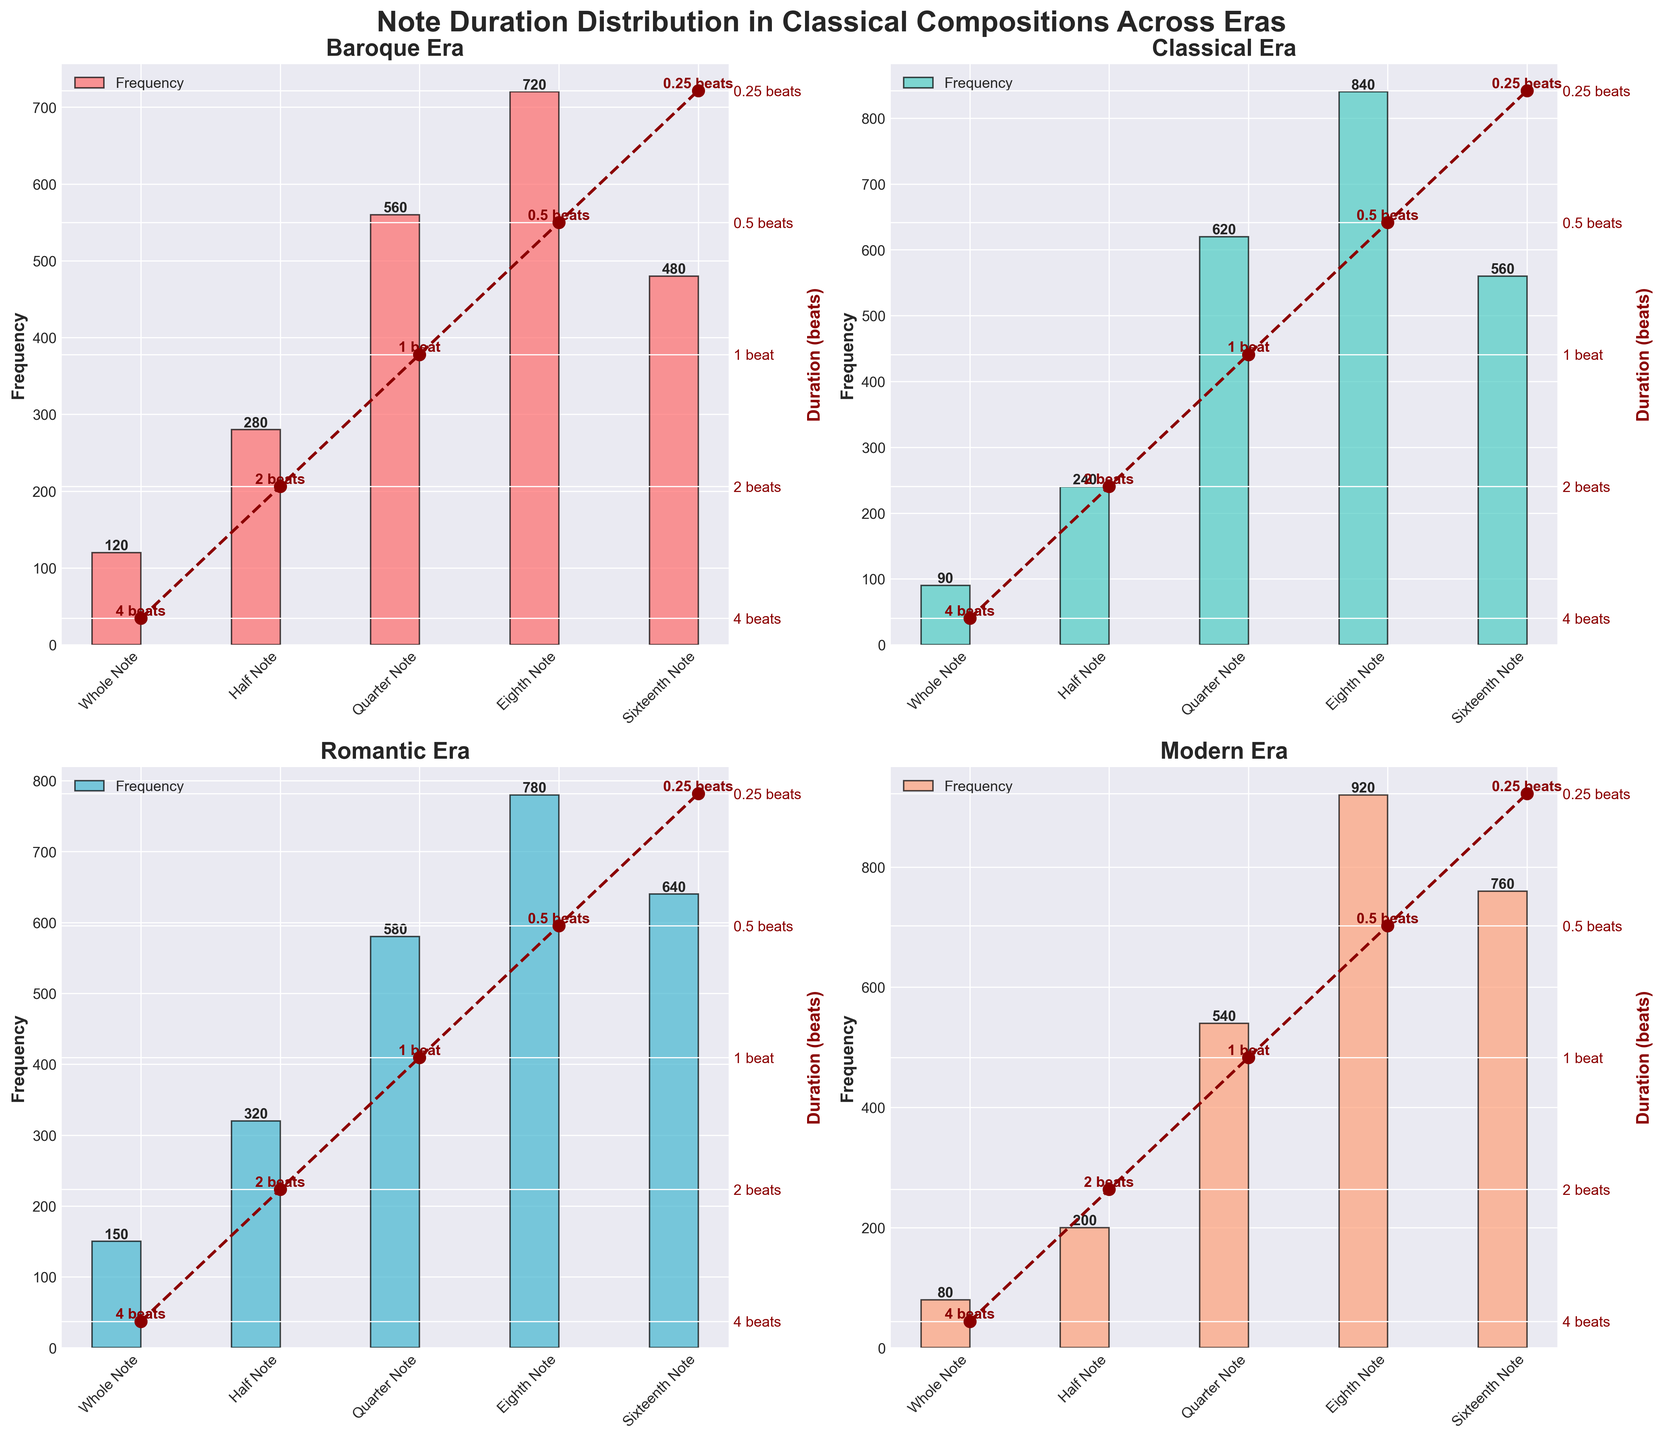What is the title of the figure? The title is the largest and topmost text, helping to contextualize the visual information. It reads "Note Duration Distribution in Classical Compositions Across Eras".
Answer: Note Duration Distribution in Classical Compositions Across Eras Which era has the highest frequency of Eighth Notes? To find the highest frequency of Eighth Notes, identify the Eighth Note for each era and compare their values. The Modern era shows the highest frequency of 920 for Eighth Notes.
Answer: Modern How many subplots are there in the figure? Count the individual charts arranged within the figure. There are a total of 4 subplots, one for each era (Baroque, Classical, Romantic, Modern).
Answer: 4 Which era has the lowest frequency of Whole Notes? Identify the bar representing Whole Notes in each subplot and compare their heights to find the smallest one. The Modern era has the lowest frequency of Whole Notes at 80.
Answer: Modern What is the difference in frequency of Half Notes between the Classical and Romantic eras? Find the frequency of Half Notes for both eras and subtract the lower from the higher. Classical has 240, and Romantic has 320, so the difference is 320 - 240 = 80.
Answer: 80 Among all the eras, which note type has the highest frequency and what is that frequency? Compare the heights of all bars across the subplots to find the highest one. The Modern era's Eighth Note has the highest frequency at 920.
Answer: Eighth Note, 920 What is the average duration of notes in the Baroque era? Convert durations to numeric values, then calculate the average. Durations (in beats): 4, 2, 1, 0.5, 0.25. Average = (4+2+1+0.5+0.25)/5 = 1.55 beats.
Answer: 1.55 beats Which era has the smallest range of note durations? Determine the range (max duration - min duration) for each era. All eras share the same range: 4 beats (Whole Note) to 0.25 beats (Sixteenth Note), hence the range is 3.75 beats for each era.
Answer: All eras have the same range Between Baroque and Modern eras, which uses shorter note durations more frequently? Compare the frequencies of shorter notes (Eighth and Sixteenth Notes) for both eras. The Modern era has higher frequencies (Eighth: 920, Sixteenth: 760) than the Baroque (Eighth: 720, Sixteenth: 480).
Answer: Modern How do the frequencies of Quarter Notes in the Classical era compare to the Romantic era? Look at the height of the Quarter Note bars in the Classical (620) and Romantic (580) eras. The Classical era has a higher frequency.
Answer: Classical is higher 